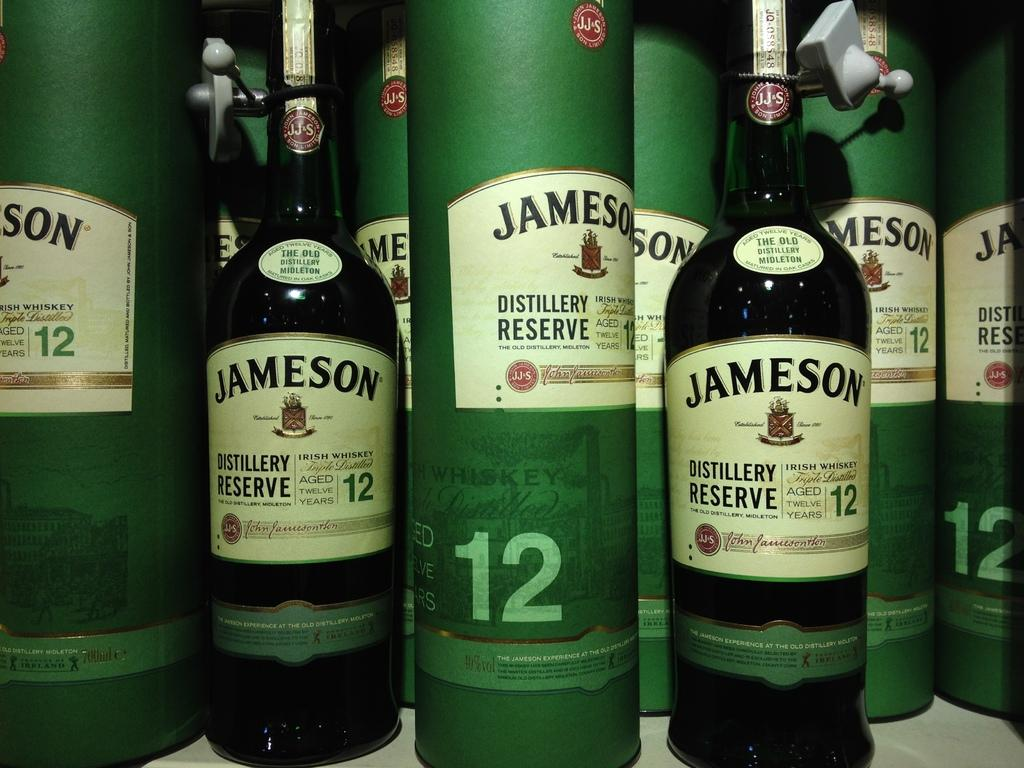<image>
Describe the image concisely. Multiple bottles of Jameson Irish Whiskey is sitting on a table. 